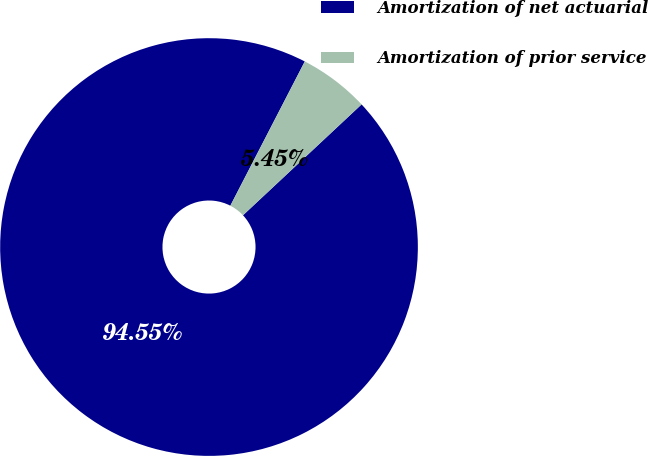<chart> <loc_0><loc_0><loc_500><loc_500><pie_chart><fcel>Amortization of net actuarial<fcel>Amortization of prior service<nl><fcel>94.55%<fcel>5.45%<nl></chart> 